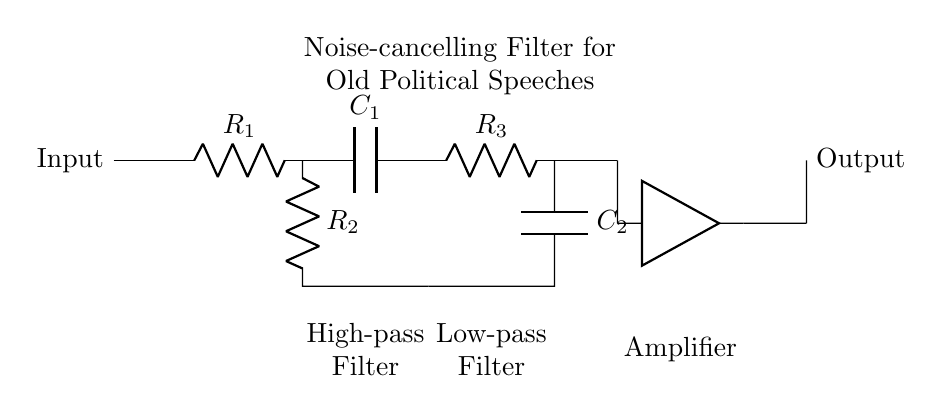What is the purpose of the capacitor C1? The capacitor C1 is used in the high-pass filter configuration, which blocks low-frequency signals while allowing high-frequency signals to pass through. This enhances clarity by reducing noise from lower-frequency components of the speech.
Answer: High-pass filter What type of filter is represented by R2 and C2? R2 and C2 together form a low-pass filter, which allows low-frequency signals to pass while blocking high-frequency noise. This is important for preserving the fundamental tones of political speeches.
Answer: Low-pass filter How many resistors are in this circuit? There are three resistors present in the circuit: R1, R2, and R3. Each of these contributes to the filtering process by affecting how signals pass through based on their frequencies.
Answer: Three What component amplifies the output of the filter? The component that amplifies the output is the amplifier located at the end of the circuit diagram. Its primary role is to increase the signal strength of the filtered audio before it reaches the output.
Answer: Amplifier What would happen if C1 were removed from the circuit? If C1 is removed, the high-pass filter function would cease to operate, causing low-frequency noise to pass through and potentially reducing the clarity of the speech. The overall performance of the noise-canceling filter would be compromised.
Answer: Reduced clarity 